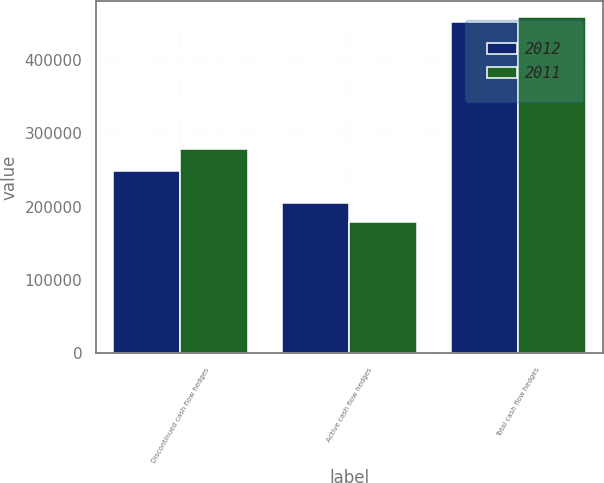Convert chart to OTSL. <chart><loc_0><loc_0><loc_500><loc_500><stacked_bar_chart><ecel><fcel>Discontinued cash flow hedges<fcel>Active cash flow hedges<fcel>Total cash flow hedges<nl><fcel>2012<fcel>247983<fcel>204358<fcel>452341<nl><fcel>2011<fcel>279091<fcel>178862<fcel>457953<nl></chart> 